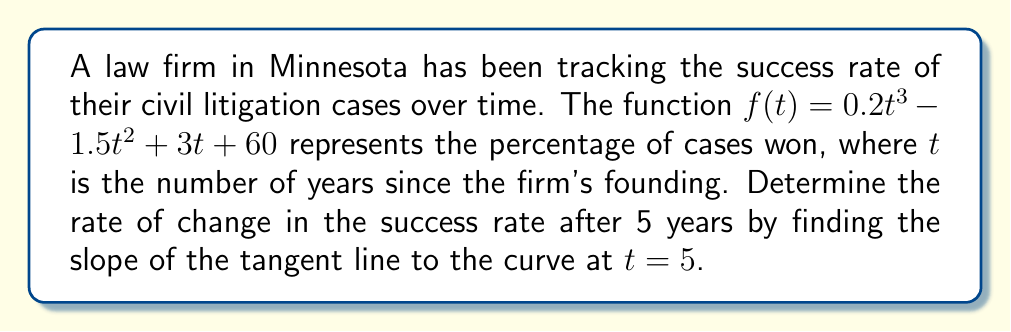Can you solve this math problem? To find the slope of the tangent line at a specific point, we need to calculate the derivative of the function and evaluate it at the given point. Let's proceed step by step:

1) The given function is:
   $f(t) = 0.2t^3 - 1.5t^2 + 3t + 60$

2) To find the derivative, we apply the power rule and constant rule:
   $f'(t) = 0.6t^2 - 3t + 3$

3) Now, we need to evaluate $f'(t)$ at $t = 5$:
   $f'(5) = 0.6(5^2) - 3(5) + 3$

4) Let's calculate:
   $f'(5) = 0.6(25) - 15 + 3$
   $f'(5) = 15 - 15 + 3$
   $f'(5) = 3$

5) The slope of the tangent line at $t = 5$ is equal to $f'(5)$, which we calculated to be 3.

This means that after 5 years, the success rate of the law firm's civil litigation cases is increasing at a rate of 3 percentage points per year.
Answer: 3 percentage points per year 